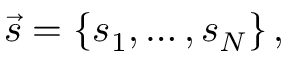<formula> <loc_0><loc_0><loc_500><loc_500>\vec { s } = \left \{ s _ { 1 } , \dots , s _ { N } \right \} ,</formula> 